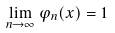Convert formula to latex. <formula><loc_0><loc_0><loc_500><loc_500>\lim _ { n \to \infty } \varphi _ { n } ( x ) = 1</formula> 